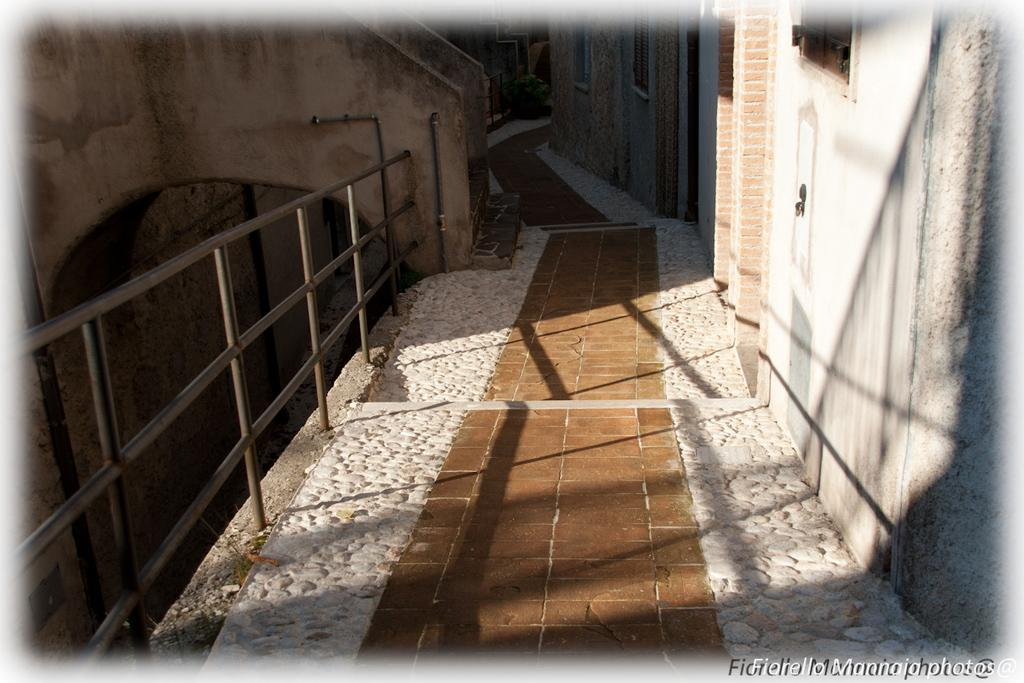What is the primary surface visible in the image? There is a floor in the image. What type of barrier is located on the left side of the image? There is fencing on the left side of the image. What type of structure is on the right side of the image? There is a wall on the right side of the image. Is there an entrance associated with the wall? Yes, there is a door associated with the wall. What can be found in the bottom right corner of the image? There is text in the bottom right corner of the image. What type of waves can be seen crashing against the wall in the image? There are no waves present in the image; it features a wall with a door and fencing on the left side. 